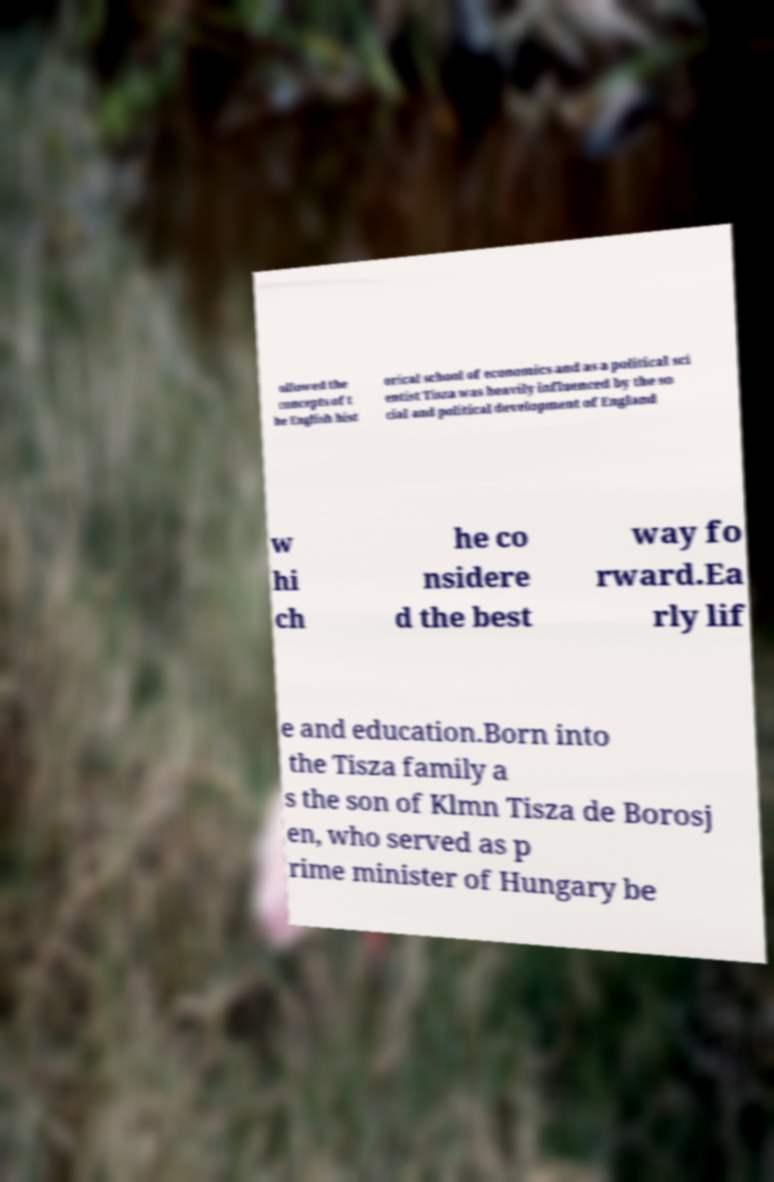Can you accurately transcribe the text from the provided image for me? ollowed the concepts of t he English hist orical school of economics and as a political sci entist Tisza was heavily influenced by the so cial and political development of England w hi ch he co nsidere d the best way fo rward.Ea rly lif e and education.Born into the Tisza family a s the son of Klmn Tisza de Borosj en, who served as p rime minister of Hungary be 